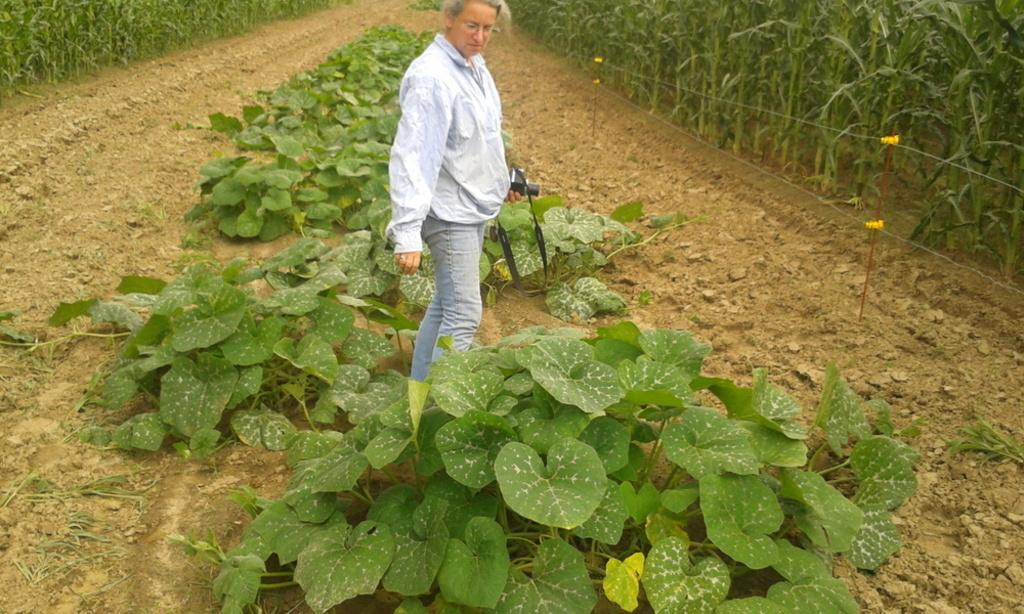What is the person in the image doing? The person is standing in the image and holding a camera. What else can be seen in the image besides the person? There are plants visible in the image. How many beetles can be seen crawling on the celery in the image? There are no beetles or celery present in the image. 